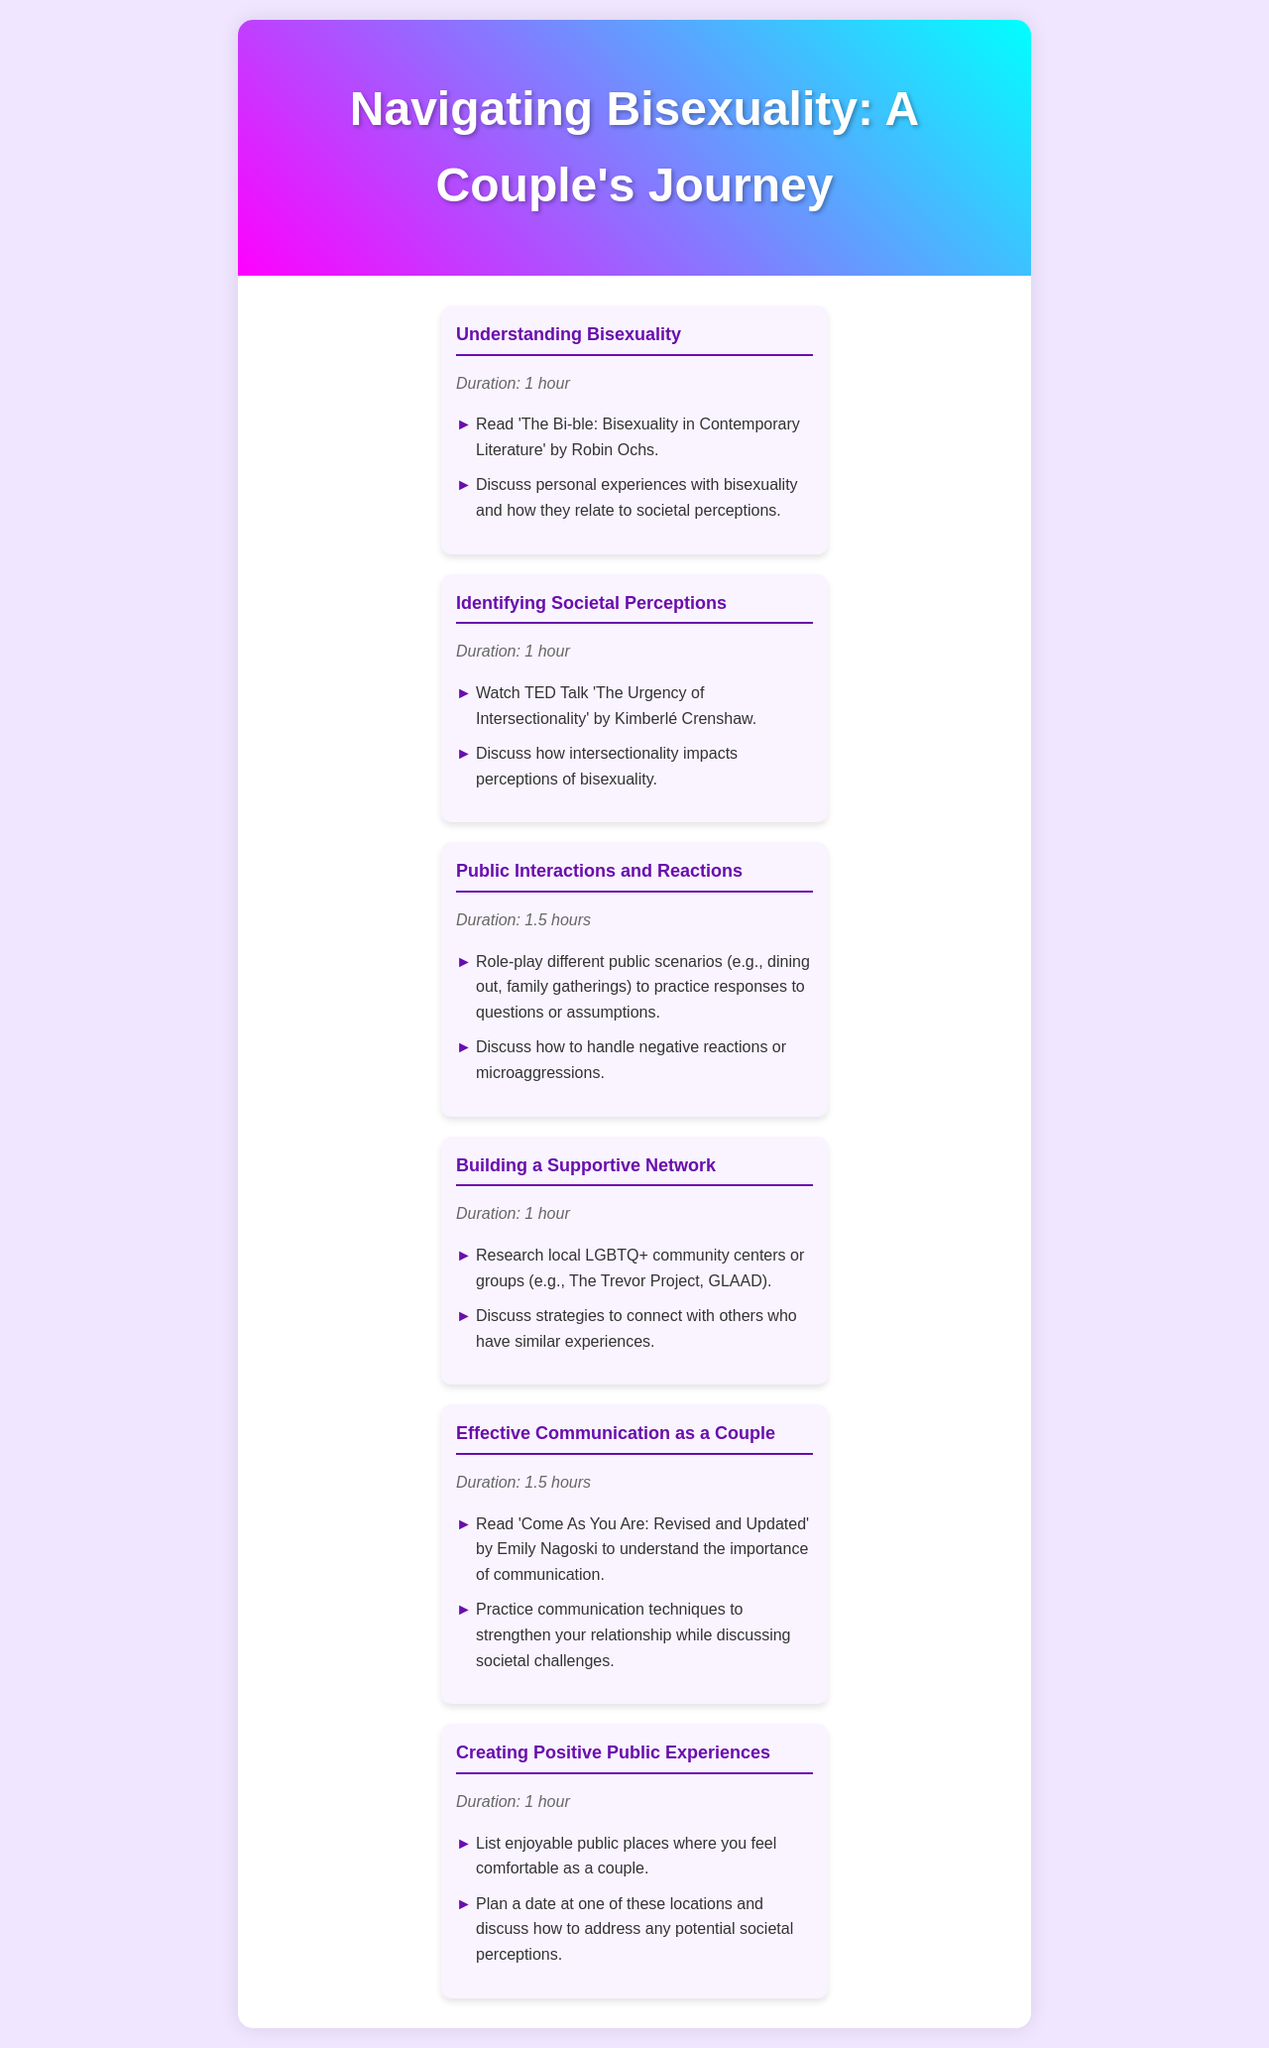What is the title of the schedule? The title of the schedule is prominently displayed at the top of the document.
Answer: Navigating Bisexuality: A Couple's Journey How many sessions are included in the schedule? The number of sessions is indicated by the count of individual sections in the schedule.
Answer: 6 What is the duration of the session titled "Public Interactions and Reactions"? The duration is listed under each session heading in the schedule.
Answer: 1.5 hours Which book is recommended for the "Effective Communication as a Couple" session? The recommended book is mentioned in the session details as part of the activities listed.
Answer: Come As You Are: Revised and Updated What is one activity listed under "Creating Positive Public Experiences"? The activities are outlined in a bullet point format within each session.
Answer: List enjoyable public places where you feel comfortable as a couple How does the session on "Identifying Societal Perceptions" relate to intersectionality? This relationship is discussed in the context of the TED Talk that is part of the session.
Answer: Impact perceptions of bisexuality 